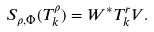Convert formula to latex. <formula><loc_0><loc_0><loc_500><loc_500>S _ { \rho , \Phi } ( T _ { k } ^ { \rho } ) = W ^ { \ast } T _ { k } ^ { r } V .</formula> 